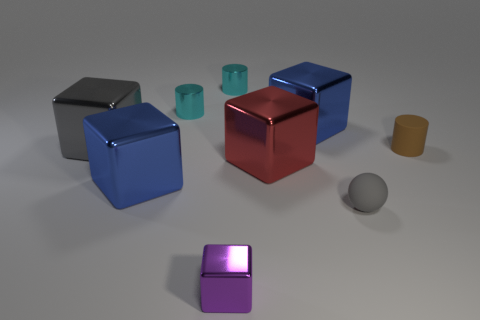How many things are either metal objects or tiny shiny things that are on the left side of the small purple object?
Give a very brief answer. 7. What material is the thing that is both in front of the red thing and behind the tiny gray thing?
Provide a short and direct response. Metal. What is the thing that is in front of the small gray matte sphere made of?
Keep it short and to the point. Metal. What is the color of the tiny cube that is the same material as the large gray block?
Your answer should be compact. Purple. There is a small brown rubber thing; is its shape the same as the tiny thing left of the purple metallic block?
Give a very brief answer. Yes. There is a ball; are there any tiny purple cubes behind it?
Your response must be concise. No. What material is the large block that is the same color as the tiny matte ball?
Provide a succinct answer. Metal. There is a brown object; is its size the same as the purple thing that is in front of the red block?
Make the answer very short. Yes. Are there any tiny balls that have the same color as the tiny block?
Keep it short and to the point. No. Is there another tiny object that has the same shape as the tiny brown object?
Provide a succinct answer. Yes. 